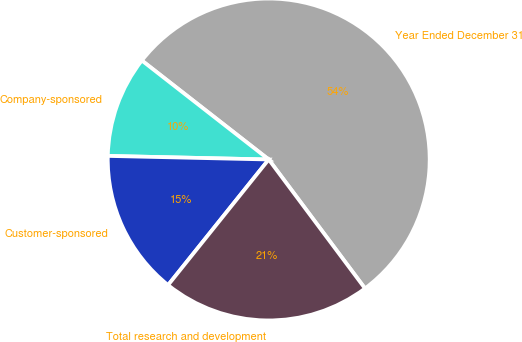Convert chart to OTSL. <chart><loc_0><loc_0><loc_500><loc_500><pie_chart><fcel>Year Ended December 31<fcel>Company-sponsored<fcel>Customer-sponsored<fcel>Total research and development<nl><fcel>54.25%<fcel>10.19%<fcel>14.6%<fcel>20.96%<nl></chart> 